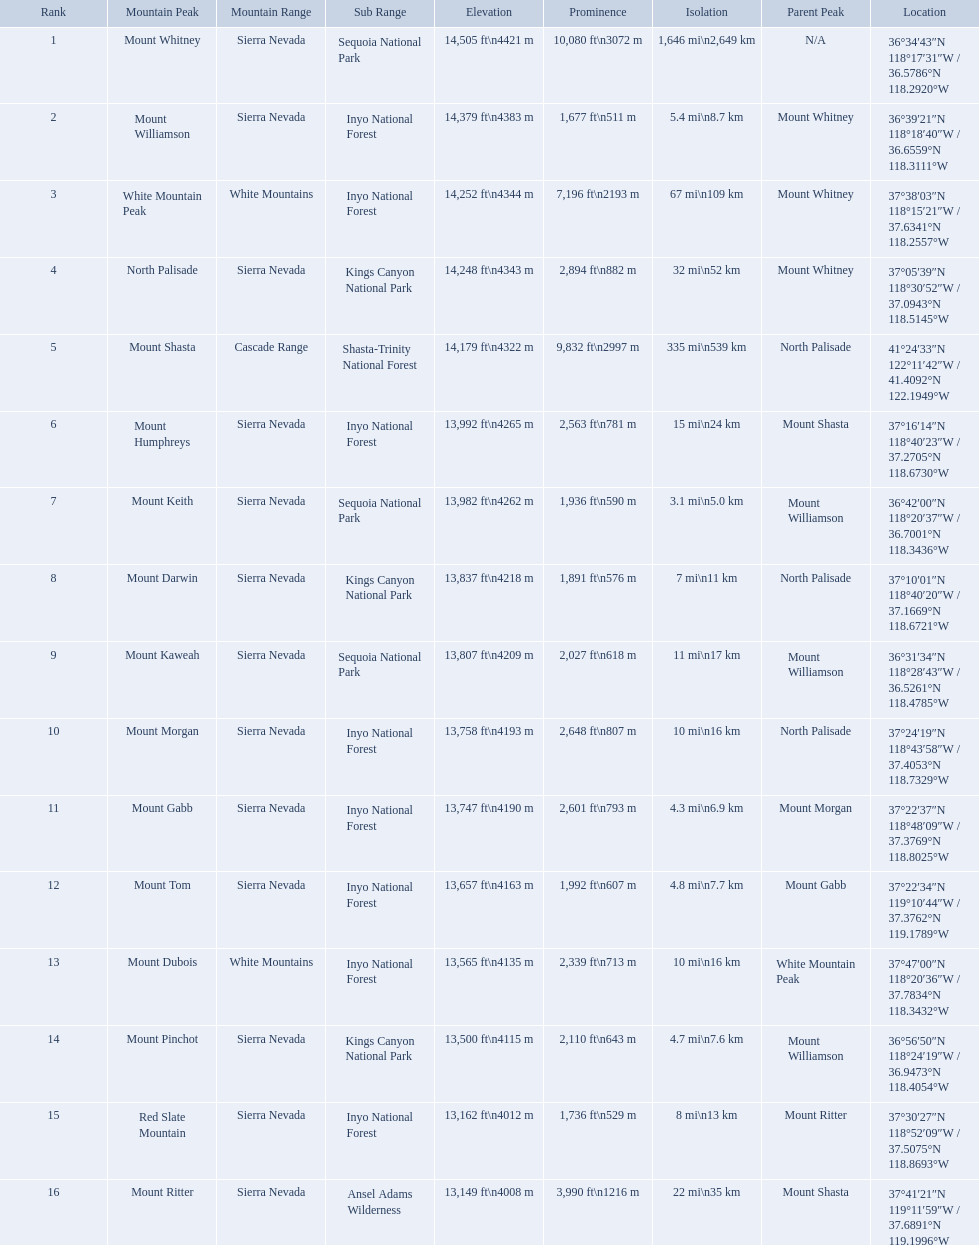What are the mountain peaks? Mount Whitney, Mount Williamson, White Mountain Peak, North Palisade, Mount Shasta, Mount Humphreys, Mount Keith, Mount Darwin, Mount Kaweah, Mount Morgan, Mount Gabb, Mount Tom, Mount Dubois, Mount Pinchot, Red Slate Mountain, Mount Ritter. Of these, which one has a prominence more than 10,000 ft? Mount Whitney. What are the heights of the californian mountain peaks? 14,505 ft\n4421 m, 14,379 ft\n4383 m, 14,252 ft\n4344 m, 14,248 ft\n4343 m, 14,179 ft\n4322 m, 13,992 ft\n4265 m, 13,982 ft\n4262 m, 13,837 ft\n4218 m, 13,807 ft\n4209 m, 13,758 ft\n4193 m, 13,747 ft\n4190 m, 13,657 ft\n4163 m, 13,565 ft\n4135 m, 13,500 ft\n4115 m, 13,162 ft\n4012 m, 13,149 ft\n4008 m. What elevation is 13,149 ft or less? 13,149 ft\n4008 m. What mountain peak is at this elevation? Mount Ritter. What are the listed elevations? 14,505 ft\n4421 m, 14,379 ft\n4383 m, 14,252 ft\n4344 m, 14,248 ft\n4343 m, 14,179 ft\n4322 m, 13,992 ft\n4265 m, 13,982 ft\n4262 m, 13,837 ft\n4218 m, 13,807 ft\n4209 m, 13,758 ft\n4193 m, 13,747 ft\n4190 m, 13,657 ft\n4163 m, 13,565 ft\n4135 m, 13,500 ft\n4115 m, 13,162 ft\n4012 m, 13,149 ft\n4008 m. Which of those is 13,149 ft or below? 13,149 ft\n4008 m. To what mountain peak does that value correspond? Mount Ritter. Which mountain peaks are lower than 14,000 ft? Mount Humphreys, Mount Keith, Mount Darwin, Mount Kaweah, Mount Morgan, Mount Gabb, Mount Tom, Mount Dubois, Mount Pinchot, Red Slate Mountain, Mount Ritter. Are any of them below 13,500? if so, which ones? Red Slate Mountain, Mount Ritter. What's the lowest peak? 13,149 ft\n4008 m. Which one is that? Mount Ritter. What are the heights of the peaks? 14,505 ft\n4421 m, 14,379 ft\n4383 m, 14,252 ft\n4344 m, 14,248 ft\n4343 m, 14,179 ft\n4322 m, 13,992 ft\n4265 m, 13,982 ft\n4262 m, 13,837 ft\n4218 m, 13,807 ft\n4209 m, 13,758 ft\n4193 m, 13,747 ft\n4190 m, 13,657 ft\n4163 m, 13,565 ft\n4135 m, 13,500 ft\n4115 m, 13,162 ft\n4012 m, 13,149 ft\n4008 m. Which of these heights is tallest? 14,505 ft\n4421 m. What peak is 14,505 feet? Mount Whitney. Which are the highest mountain peaks in california? Mount Whitney, Mount Williamson, White Mountain Peak, North Palisade, Mount Shasta, Mount Humphreys, Mount Keith, Mount Darwin, Mount Kaweah, Mount Morgan, Mount Gabb, Mount Tom, Mount Dubois, Mount Pinchot, Red Slate Mountain, Mount Ritter. Of those, which are not in the sierra nevada range? White Mountain Peak, Mount Shasta, Mount Dubois. Of the mountains not in the sierra nevada range, which is the only mountain in the cascades? Mount Shasta. 